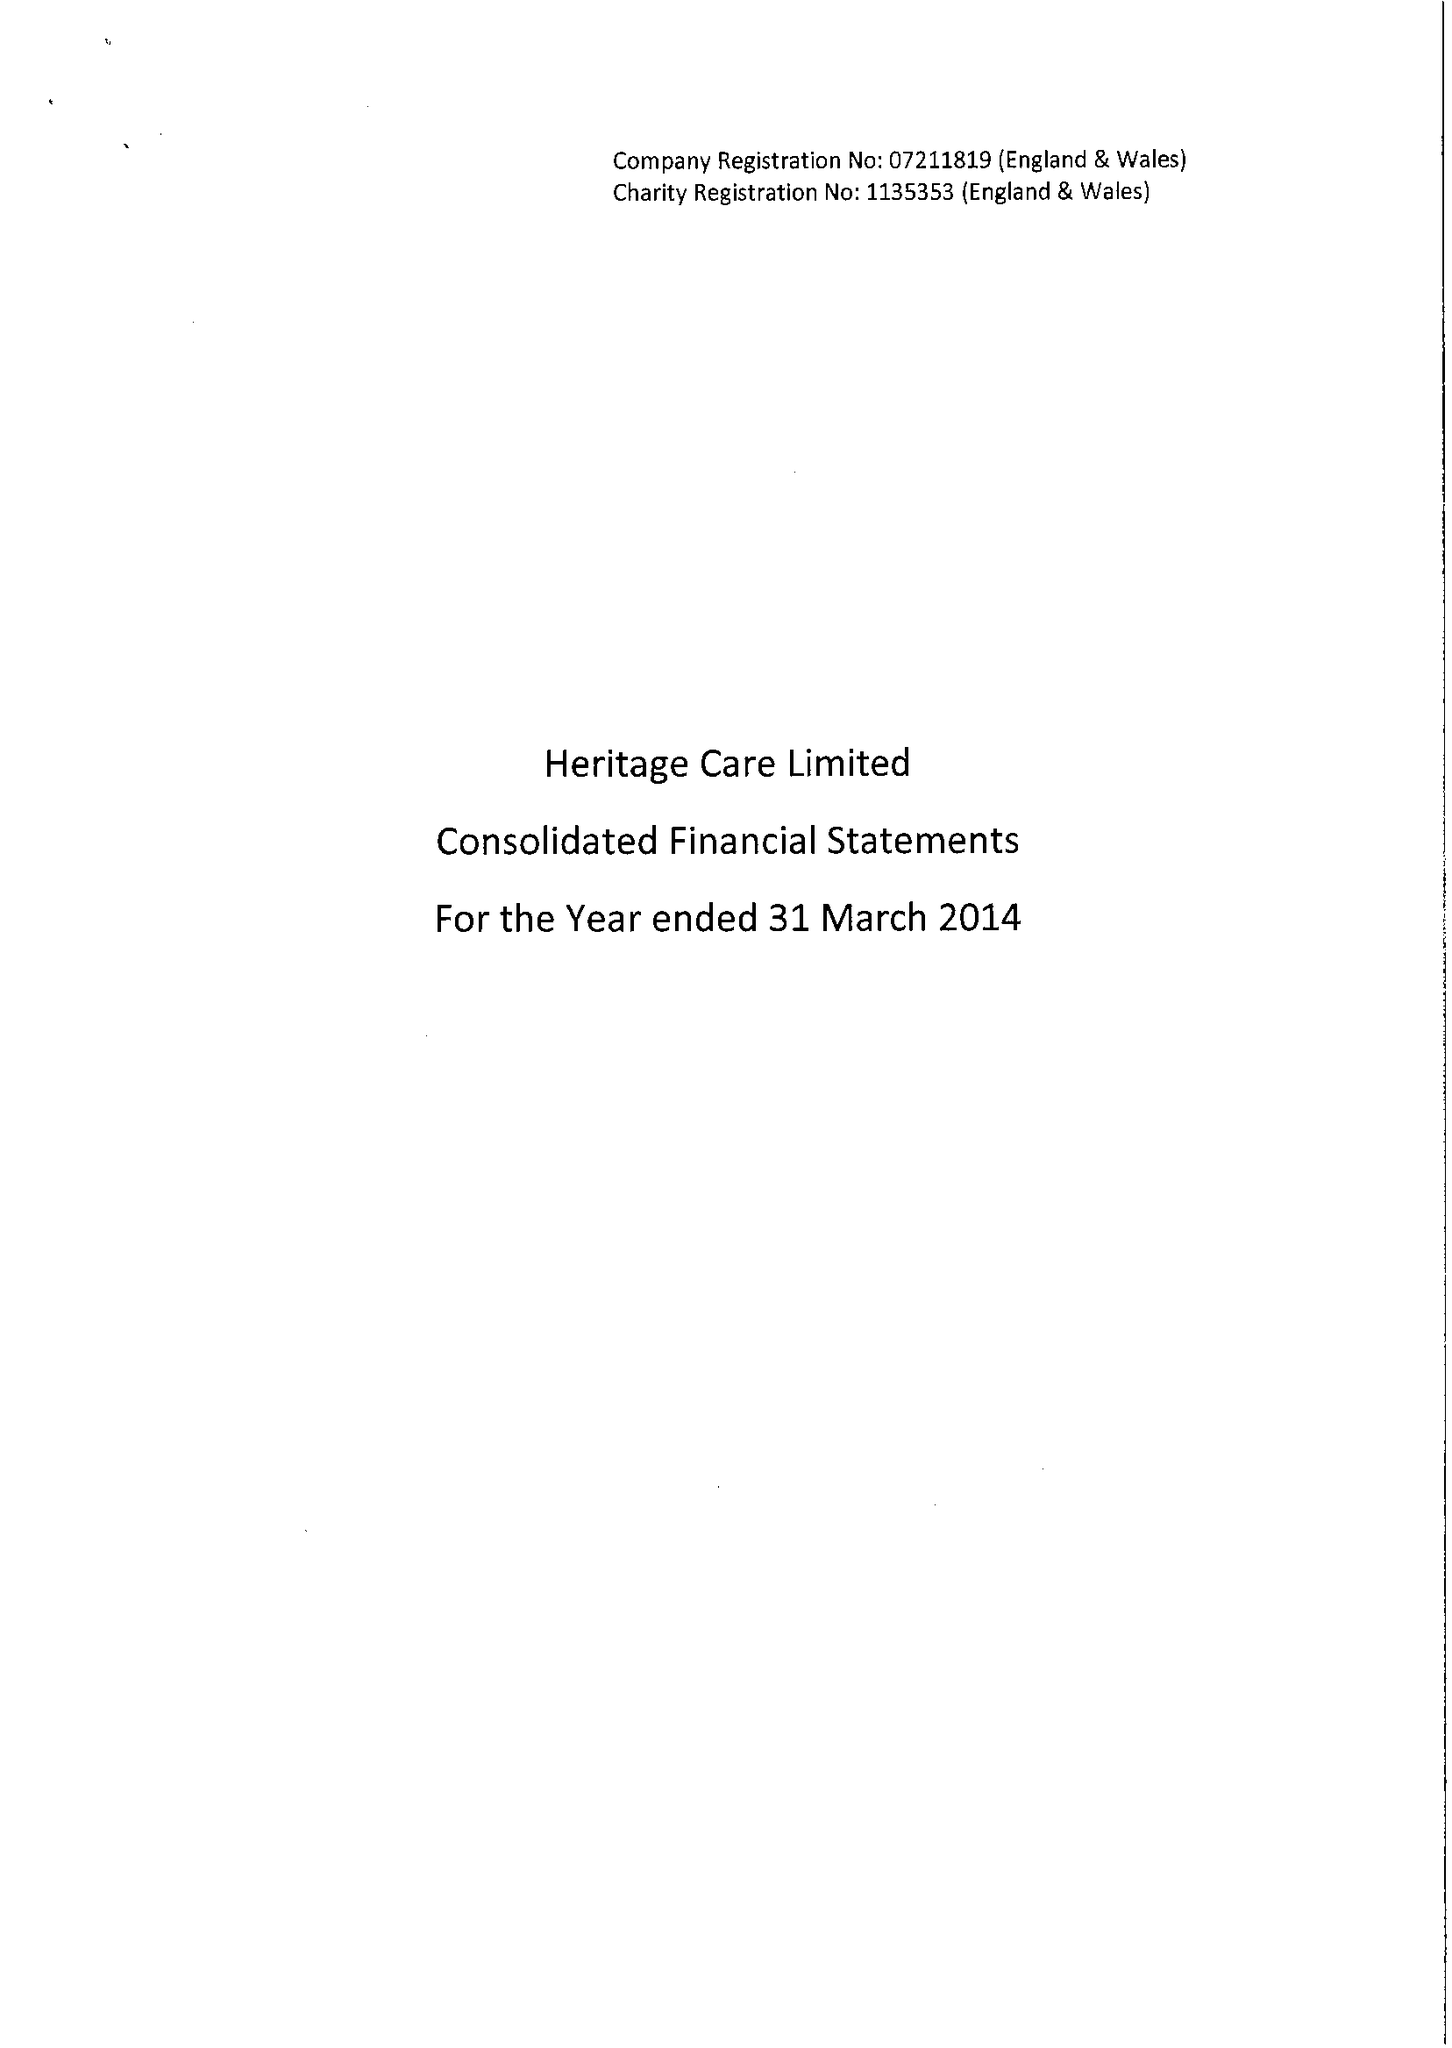What is the value for the spending_annually_in_british_pounds?
Answer the question using a single word or phrase. 37184000.00 